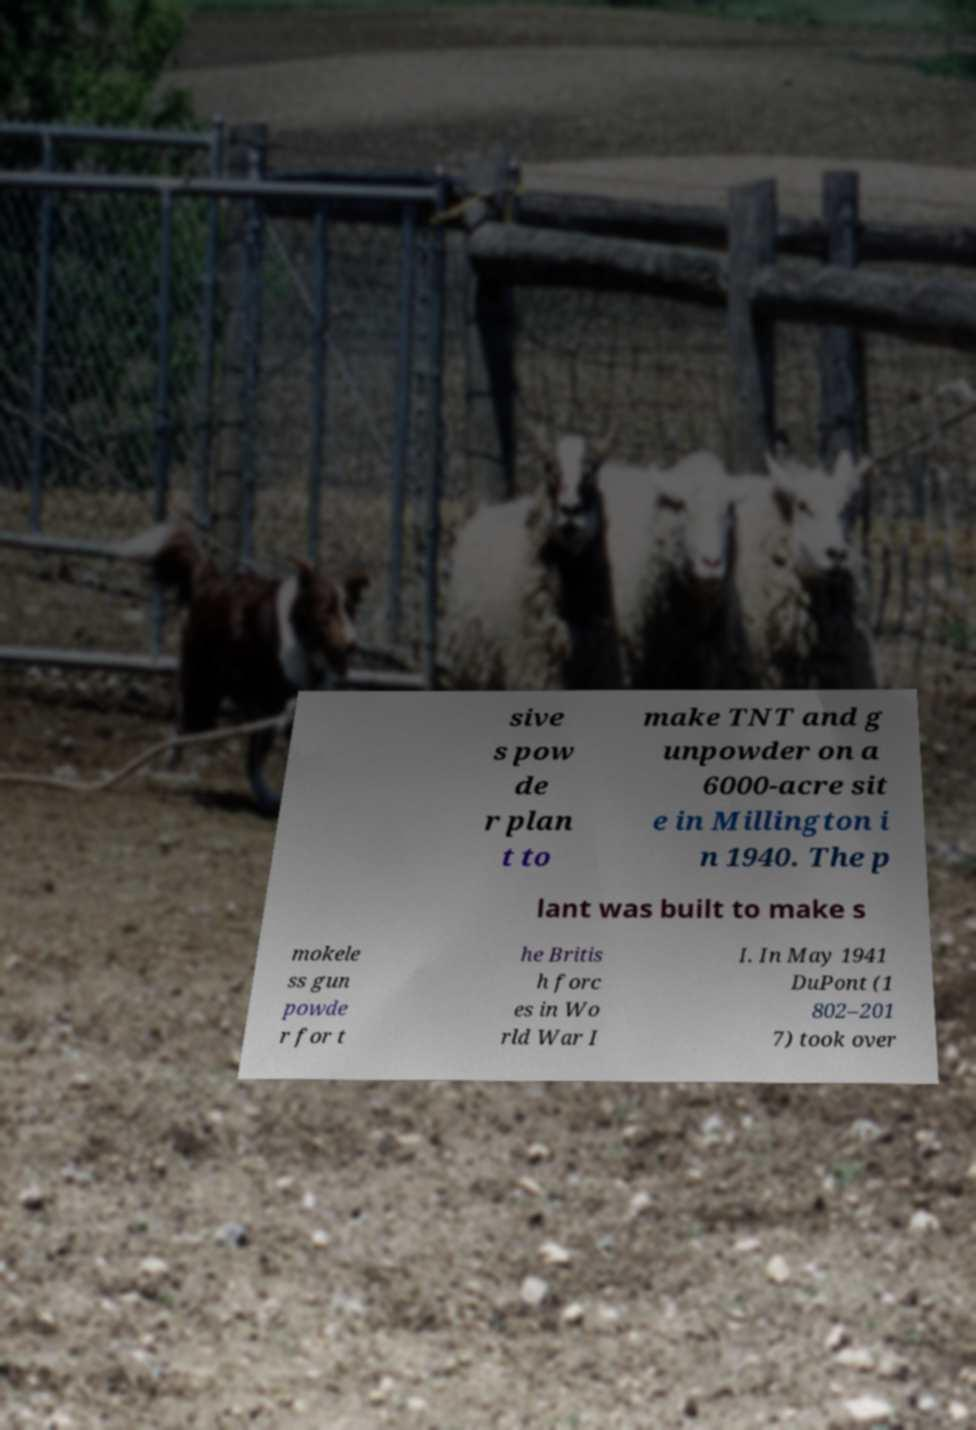Could you extract and type out the text from this image? sive s pow de r plan t to make TNT and g unpowder on a 6000-acre sit e in Millington i n 1940. The p lant was built to make s mokele ss gun powde r for t he Britis h forc es in Wo rld War I I. In May 1941 DuPont (1 802–201 7) took over 